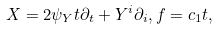Convert formula to latex. <formula><loc_0><loc_0><loc_500><loc_500>X = 2 \psi _ { Y } t \partial _ { t } + Y ^ { i } \partial _ { i } , f = c _ { 1 } t ,</formula> 